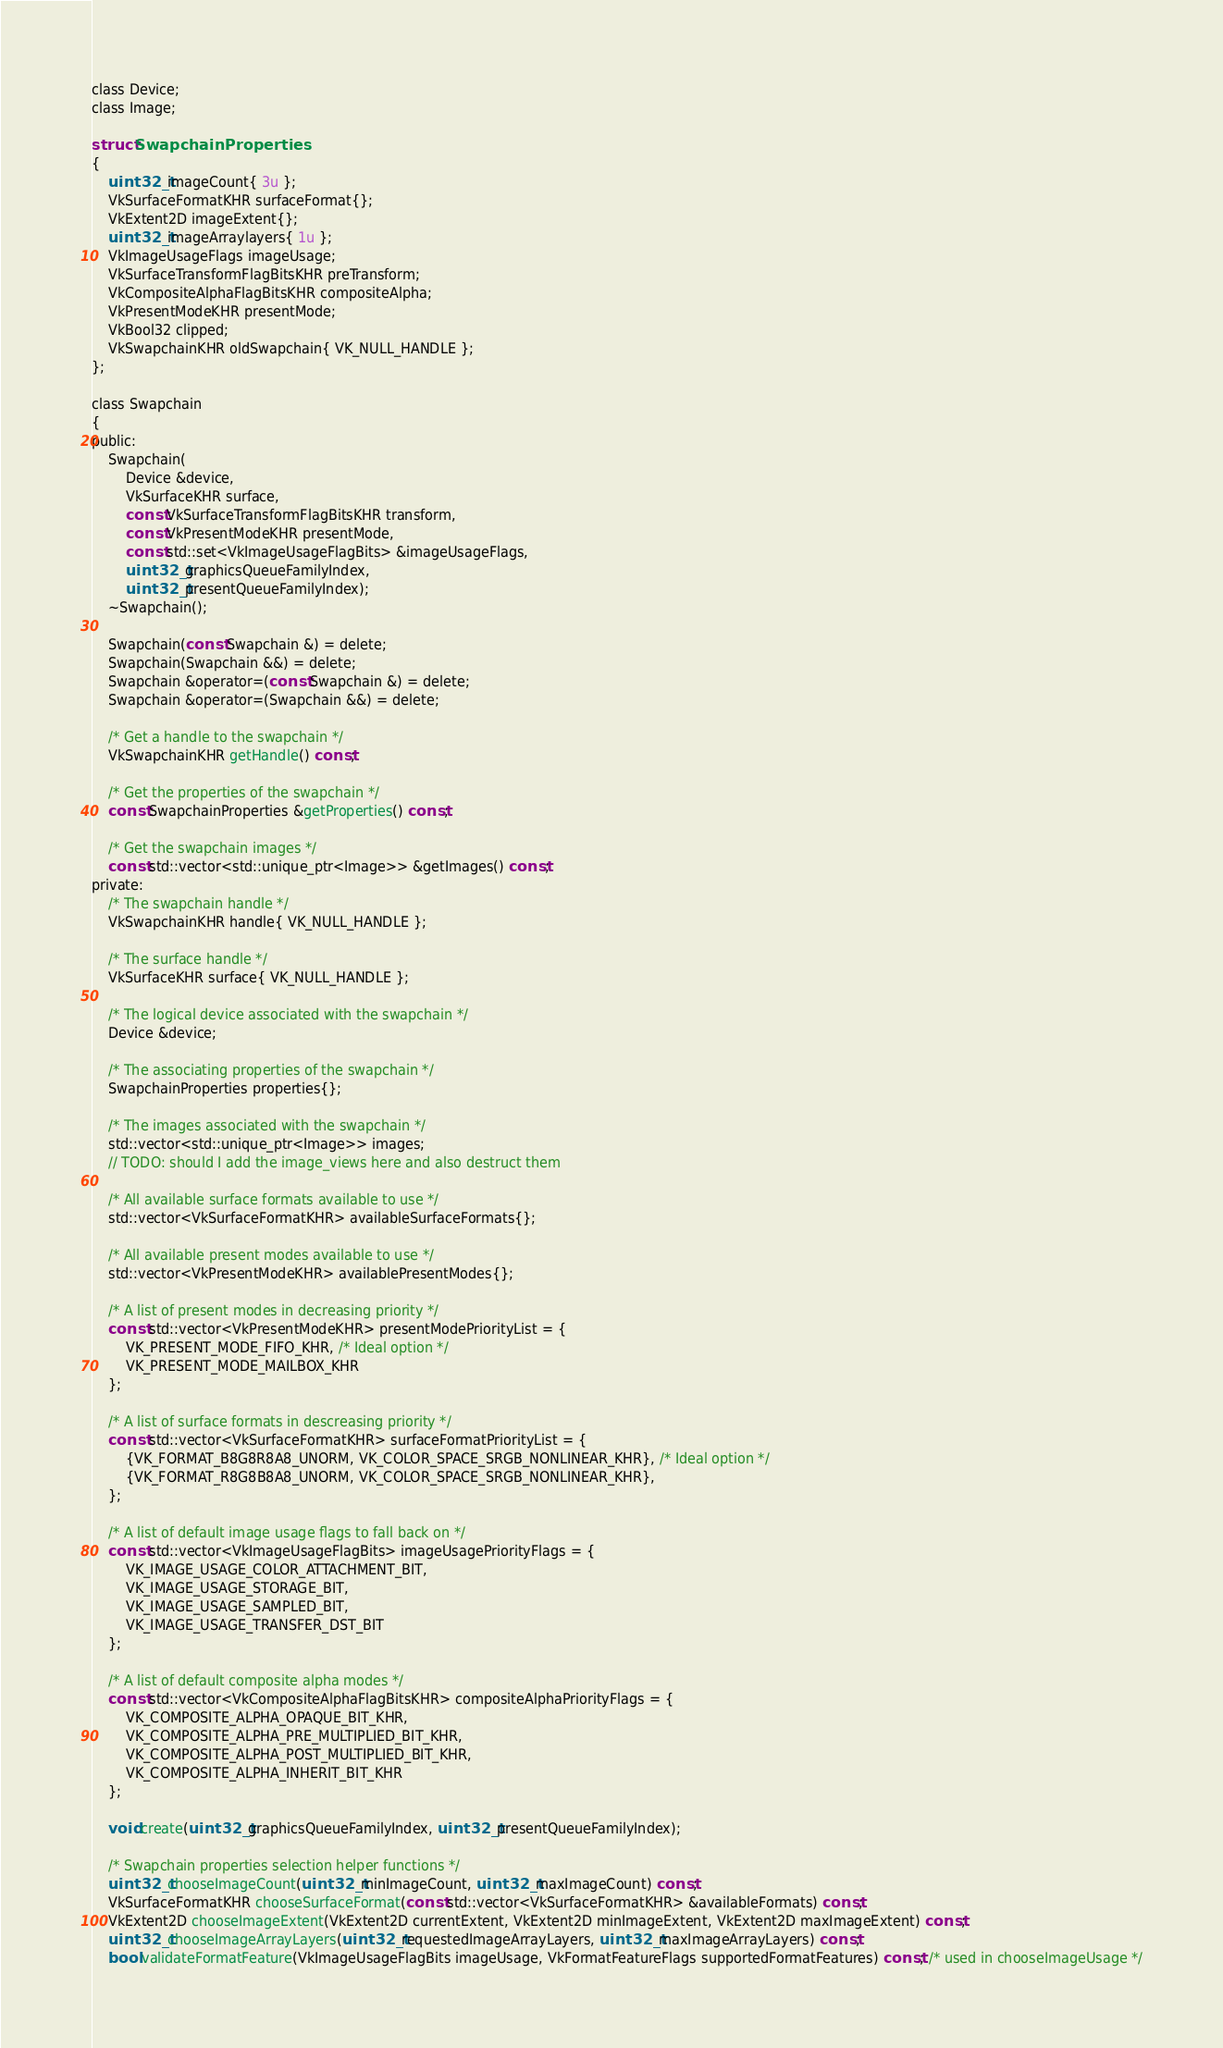<code> <loc_0><loc_0><loc_500><loc_500><_C_>
class Device;
class Image;

struct SwapchainProperties
{
	uint32_t imageCount{ 3u };
	VkSurfaceFormatKHR surfaceFormat{};
	VkExtent2D imageExtent{};
	uint32_t imageArraylayers{ 1u };
	VkImageUsageFlags imageUsage;
	VkSurfaceTransformFlagBitsKHR preTransform;
	VkCompositeAlphaFlagBitsKHR compositeAlpha;
	VkPresentModeKHR presentMode;
	VkBool32 clipped;
	VkSwapchainKHR oldSwapchain{ VK_NULL_HANDLE };
};

class Swapchain
{
public:
	Swapchain(
		Device &device,
		VkSurfaceKHR surface,
		const VkSurfaceTransformFlagBitsKHR transform,
		const VkPresentModeKHR presentMode,
		const std::set<VkImageUsageFlagBits> &imageUsageFlags,
		uint32_t graphicsQueueFamilyIndex,
		uint32_t presentQueueFamilyIndex);
	~Swapchain();

	Swapchain(const Swapchain &) = delete;
	Swapchain(Swapchain &&) = delete;
	Swapchain &operator=(const Swapchain &) = delete;
	Swapchain &operator=(Swapchain &&) = delete;

	/* Get a handle to the swapchain */
	VkSwapchainKHR getHandle() const;

	/* Get the properties of the swapchain */
	const SwapchainProperties &getProperties() const;

	/* Get the swapchain images */
	const std::vector<std::unique_ptr<Image>> &getImages() const;
private:
	/* The swapchain handle */
	VkSwapchainKHR handle{ VK_NULL_HANDLE };

	/* The surface handle */
	VkSurfaceKHR surface{ VK_NULL_HANDLE };

	/* The logical device associated with the swapchain */
	Device &device;

	/* The associating properties of the swapchain */
	SwapchainProperties properties{};
	
	/* The images associated with the swapchain */
	std::vector<std::unique_ptr<Image>> images;
	// TODO: should I add the image_views here and also destruct them

	/* All available surface formats available to use */
	std::vector<VkSurfaceFormatKHR> availableSurfaceFormats{};

	/* All available present modes available to use */
	std::vector<VkPresentModeKHR> availablePresentModes{};

	/* A list of present modes in decreasing priority */
	const std::vector<VkPresentModeKHR> presentModePriorityList = {
		VK_PRESENT_MODE_FIFO_KHR, /* Ideal option */
		VK_PRESENT_MODE_MAILBOX_KHR
	};

	/* A list of surface formats in descreasing priority */
	const std::vector<VkSurfaceFormatKHR> surfaceFormatPriorityList = {
		{VK_FORMAT_B8G8R8A8_UNORM, VK_COLOR_SPACE_SRGB_NONLINEAR_KHR}, /* Ideal option */
		{VK_FORMAT_R8G8B8A8_UNORM, VK_COLOR_SPACE_SRGB_NONLINEAR_KHR},
	};

	/* A list of default image usage flags to fall back on */
	const std::vector<VkImageUsageFlagBits> imageUsagePriorityFlags = {
		VK_IMAGE_USAGE_COLOR_ATTACHMENT_BIT,
		VK_IMAGE_USAGE_STORAGE_BIT,
		VK_IMAGE_USAGE_SAMPLED_BIT,
		VK_IMAGE_USAGE_TRANSFER_DST_BIT
	};

	/* A list of default composite alpha modes */
	const std::vector<VkCompositeAlphaFlagBitsKHR> compositeAlphaPriorityFlags = {
		VK_COMPOSITE_ALPHA_OPAQUE_BIT_KHR,
		VK_COMPOSITE_ALPHA_PRE_MULTIPLIED_BIT_KHR,
		VK_COMPOSITE_ALPHA_POST_MULTIPLIED_BIT_KHR,
		VK_COMPOSITE_ALPHA_INHERIT_BIT_KHR
	};

	void create(uint32_t graphicsQueueFamilyIndex, uint32_t presentQueueFamilyIndex);

	/* Swapchain properties selection helper functions */
	uint32_t chooseImageCount(uint32_t minImageCount, uint32_t maxImageCount) const;
	VkSurfaceFormatKHR chooseSurfaceFormat(const std::vector<VkSurfaceFormatKHR> &availableFormats) const;
	VkExtent2D chooseImageExtent(VkExtent2D currentExtent, VkExtent2D minImageExtent, VkExtent2D maxImageExtent) const;
	uint32_t chooseImageArrayLayers(uint32_t requestedImageArrayLayers, uint32_t maxImageArrayLayers) const;
	bool validateFormatFeature(VkImageUsageFlagBits imageUsage, VkFormatFeatureFlags supportedFormatFeatures) const; /* used in chooseImageUsage */</code> 